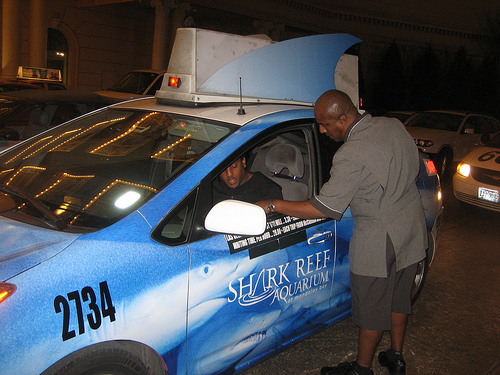<image>
Is there a man to the left of the man? Yes. From this viewpoint, the man is positioned to the left side relative to the man. Is there a man in the car? No. The man is not contained within the car. These objects have a different spatial relationship. 